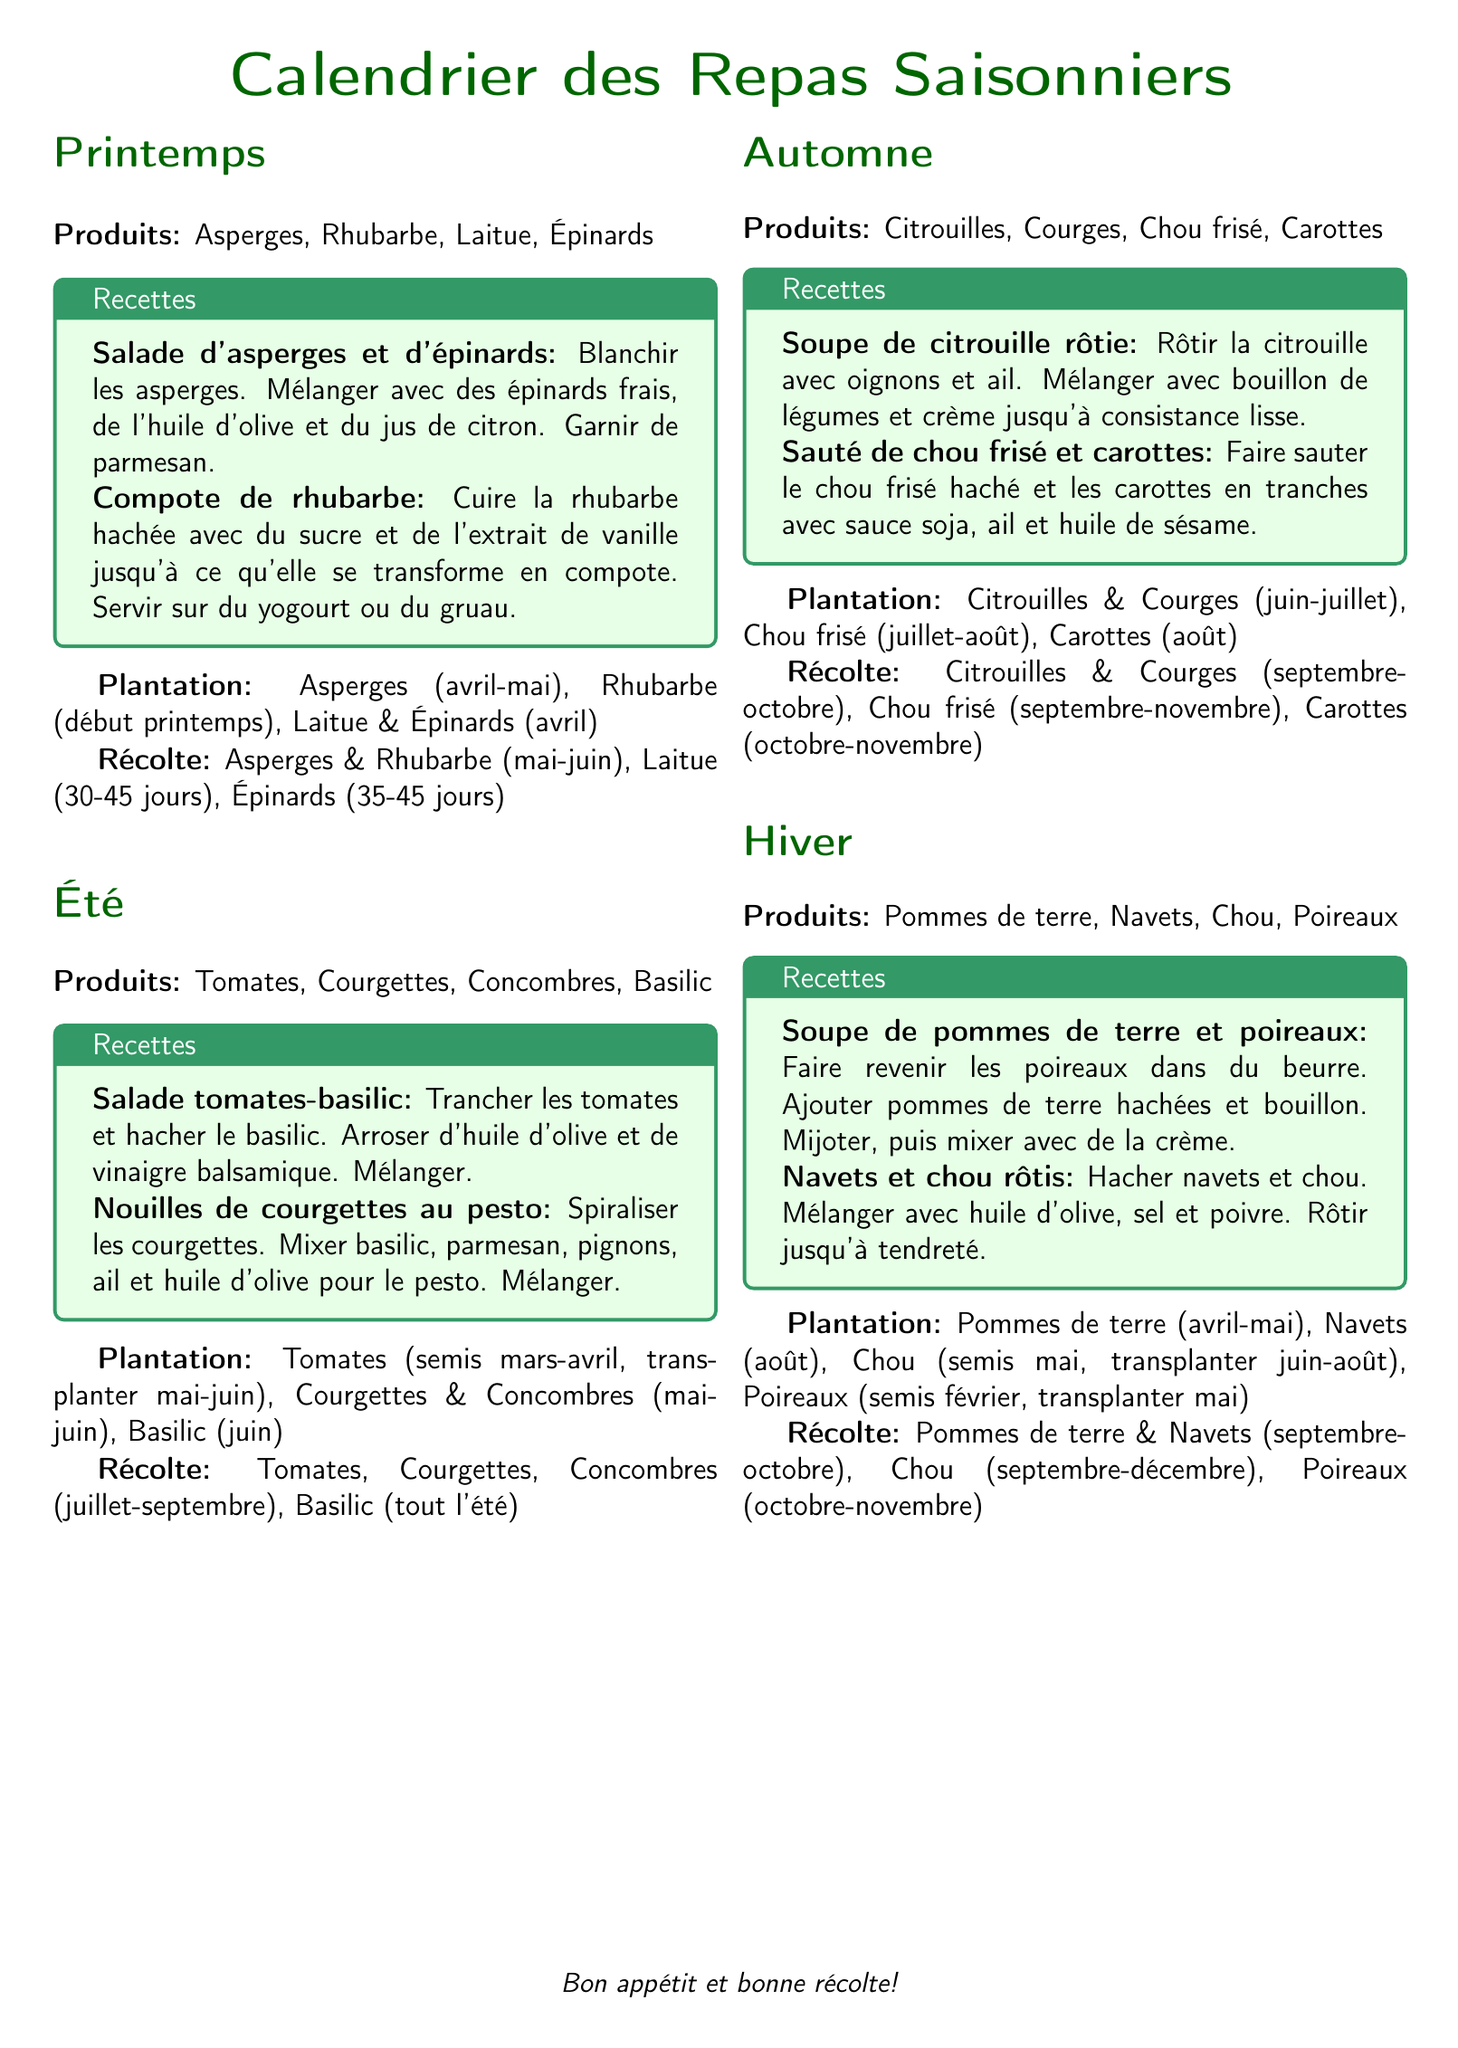Quel légumes sont produits au printemps ? Les légumes mentionnés pour le printemps dans le document sont les asperges, la rhubarbe, la laitue et les épinards.
Answer: Asperges, Rhubarbe, Laitue, Épinards Quand doit-on planter la rhubarbe ? La rhubarbe doit être plantée au début du printemps, comme indiqué dans le calendrier de plantation.
Answer: Début printemps Quel type de recette peut-on prépare avec des tomates et du basilic ? On peut préparer une salade de tomates et de basilic, comme mentionné dans la section des recettes d'été.
Answer: Salade tomates-basilic Quel est le délai de récolte pour les épinards ? Les épinards peuvent être récoltés après 35 à 45 jours, selon le calendrier de récolte du document.
Answer: 35-45 jours Quels produits de saison peut-on récolter en automne ? Les produits de saison en automne incluent les citrouilles, les courges, le chou frisé et les carottes.
Answer: Citrouilles, Courges, Chou frisé, Carottes Combien de temps faut-il pour récolter des carottes ? Les carottes se récoltent fin octobre à novembre, selon la période mentionnée dans le document.
Answer: Octobre-novembre Quel est le principal ingrédient dans la soupe de pommes de terre et poireaux ? Le principal ingrédient de la soupe mentionnée est les pommes de terre, selon la recette fournie.
Answer: Pommes de terre Quand peut-on récolter les poireaux ? Les poireaux sont récoltés entre octobre et novembre, comme indiqué dans le calendrier de récolte.
Answer: Octobre-novembre 